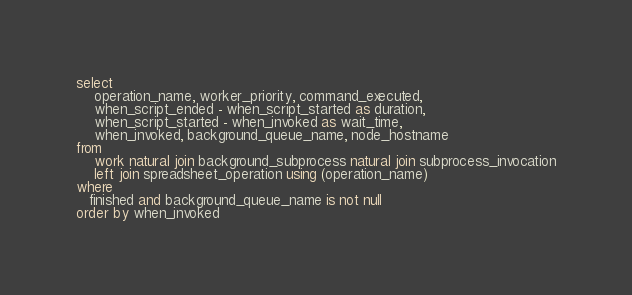Convert code to text. <code><loc_0><loc_0><loc_500><loc_500><_SQL_>
select
    operation_name, worker_priority, command_executed,
    when_script_ended - when_script_started as duration,
    when_script_started - when_invoked as wait_time,
    when_invoked, background_queue_name, node_hostname
from
    work natural join background_subprocess natural join subprocess_invocation
    left join spreadsheet_operation using (operation_name)
where
   finished and background_queue_name is not null
order by when_invoked
</code> 